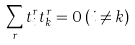Convert formula to latex. <formula><loc_0><loc_0><loc_500><loc_500>\sum _ { r } t _ { i } ^ { r } t _ { k } ^ { r } = 0 \, ( i \neq k )</formula> 